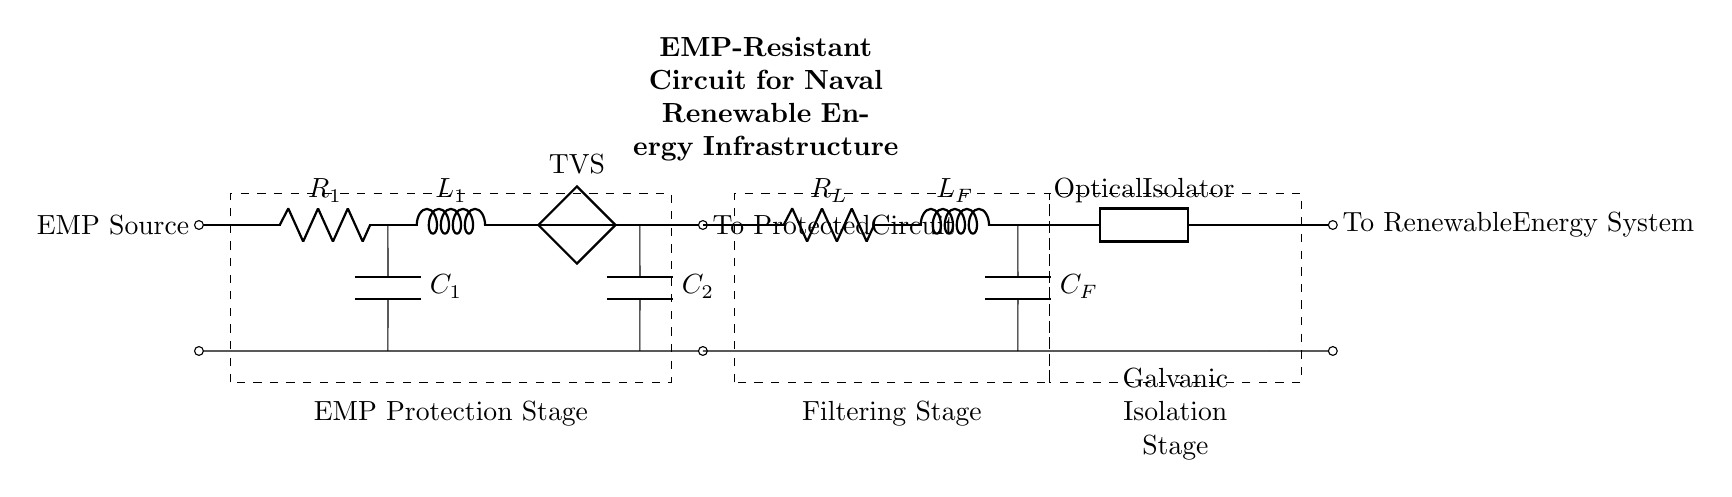What is the first component connected to the EMP source? The first component connected directly to the EMP source is a resistor labeled R1. This is identified by tracing the connection from the left side of the diagram where the EMP source is, leading directly to R1.
Answer: R1 What type of component is used for transient voltage suppression? The circuit includes a component labeled TVS, which stands for transient voltage suppressor. It can be found along the connections towards the PCB, after the inductor L1.
Answer: TVS How many stages are defined in the circuit diagram? The circuit diagram clearly shows three stages: EMP Protection Stage, Filtering Stage, and Galvanic Isolation Stage. Each stage is marked by dashed rectangles in the layout of the components.
Answer: Three What is the role of the component labeled as Optical Isolator? The Optical Isolator is used to provide galvanic isolation, which means it prevents direct electrical connection between two circuits while allowing optical signals to pass through. This is crucial in protecting sensitive renewable energy systems from EMP and electrical noise.
Answer: Galvanic isolation What is the purpose of the capacitor labeled C2? Capacitor C2 is part of the EMP Protection Stage and is used to filter out high-frequency noise and stabilize voltage levels in the circuit, helping to protect downstream components from disturbances caused by EMP events.
Answer: Filter high-frequency noise What is the value of resistance labeled R_L? The specific numerical value for R_L is not provided in the diagram, as it is represented as a general resistor label. However, it serves as the load resistor in the circuit that impacts overall current flow and performance.
Answer: Not specified 